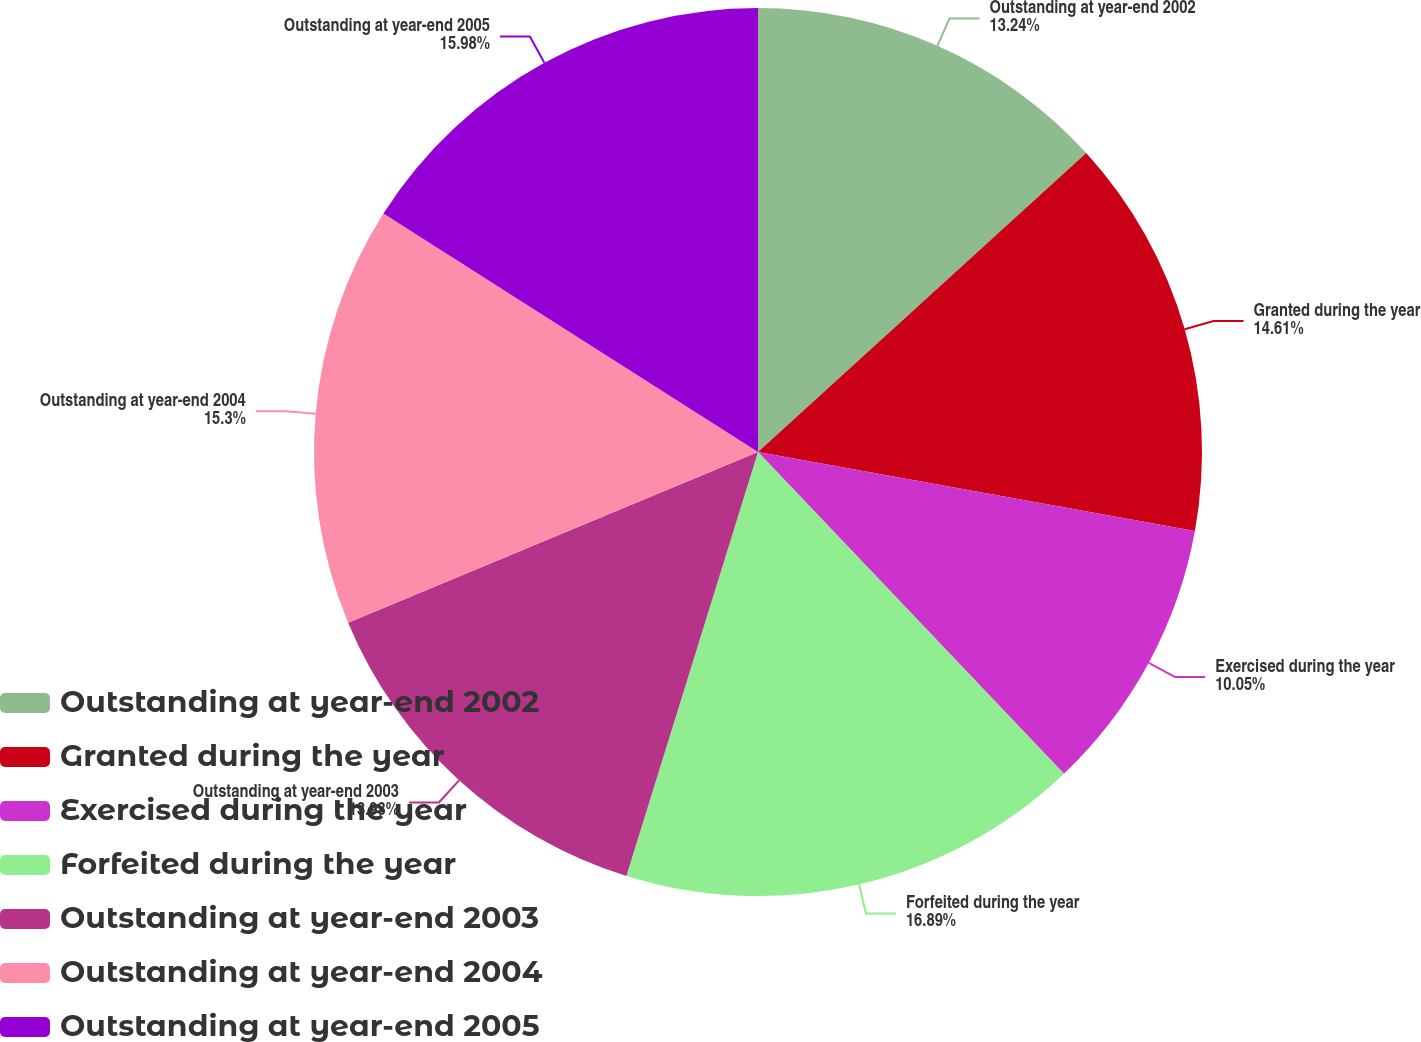<chart> <loc_0><loc_0><loc_500><loc_500><pie_chart><fcel>Outstanding at year-end 2002<fcel>Granted during the year<fcel>Exercised during the year<fcel>Forfeited during the year<fcel>Outstanding at year-end 2003<fcel>Outstanding at year-end 2004<fcel>Outstanding at year-end 2005<nl><fcel>13.24%<fcel>14.61%<fcel>10.05%<fcel>16.89%<fcel>13.93%<fcel>15.3%<fcel>15.98%<nl></chart> 